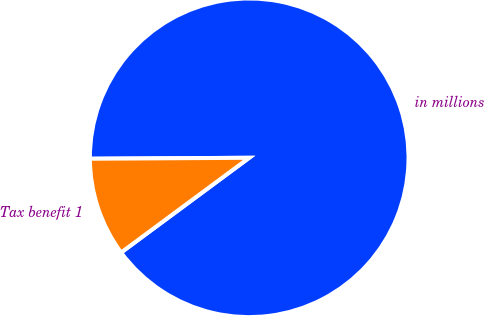<chart> <loc_0><loc_0><loc_500><loc_500><pie_chart><fcel>in millions<fcel>Tax benefit 1<nl><fcel>89.96%<fcel>10.04%<nl></chart> 